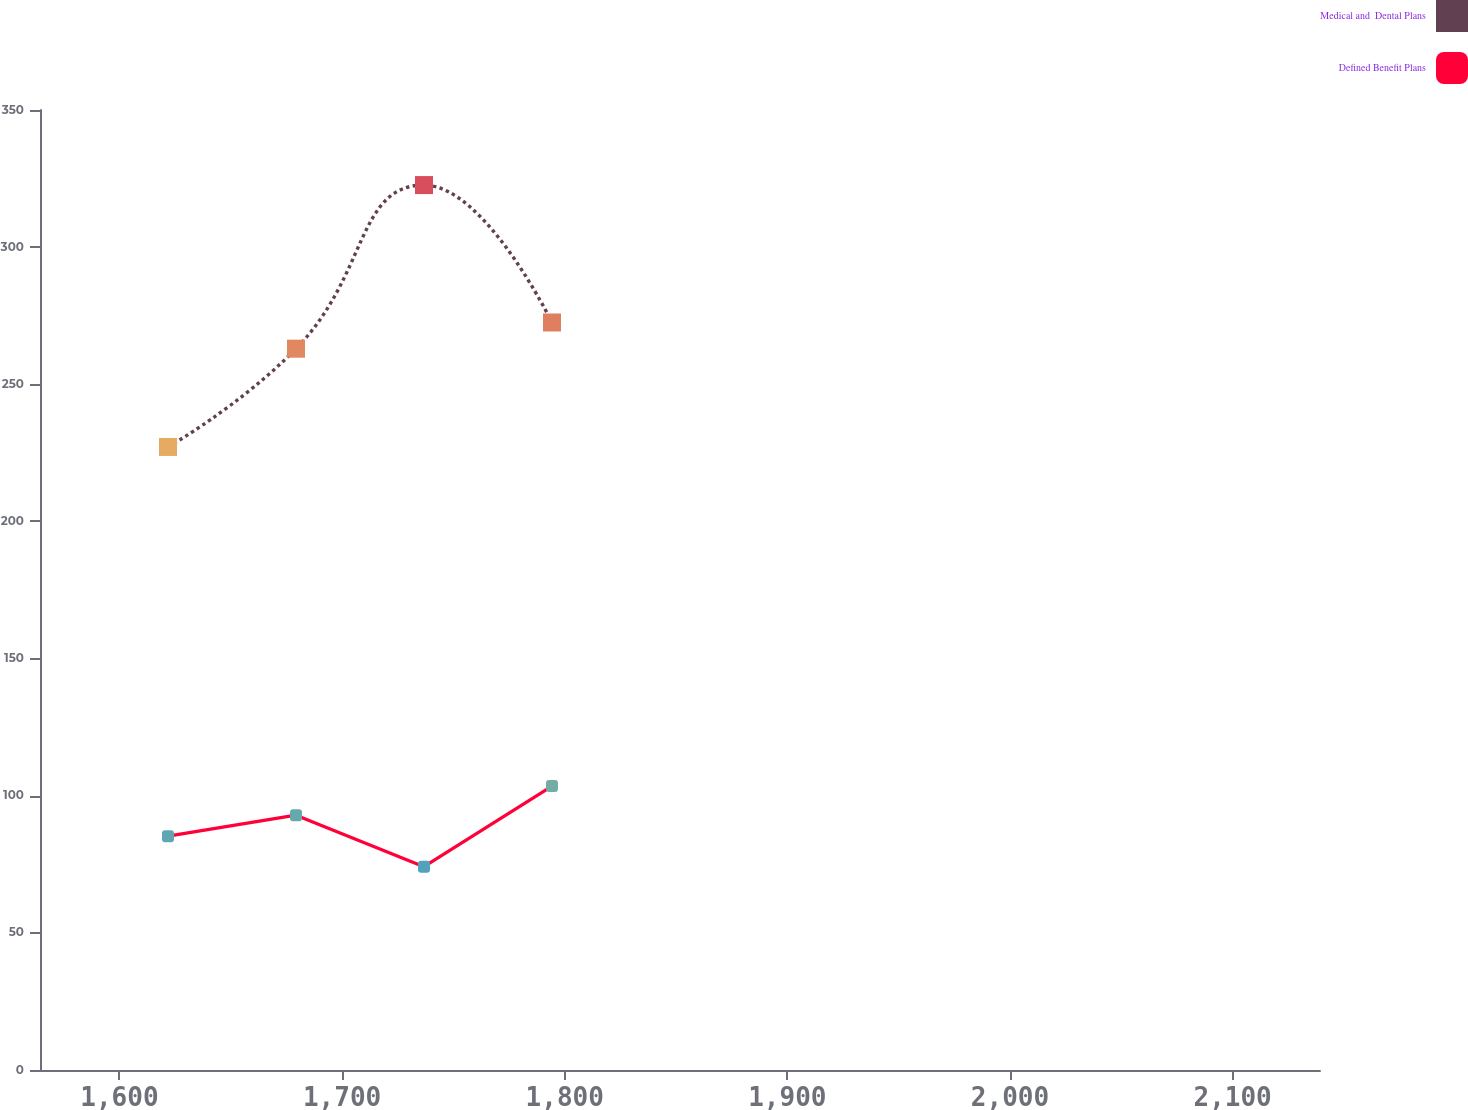Convert chart to OTSL. <chart><loc_0><loc_0><loc_500><loc_500><line_chart><ecel><fcel>Medical and  Dental Plans<fcel>Defined Benefit Plans<nl><fcel>1621.81<fcel>227.15<fcel>85.25<nl><fcel>1679.3<fcel>262.98<fcel>92.91<nl><fcel>1736.79<fcel>322.63<fcel>74.13<nl><fcel>1794.28<fcel>272.53<fcel>103.5<nl><fcel>2196.74<fcel>282.08<fcel>100.71<nl></chart> 